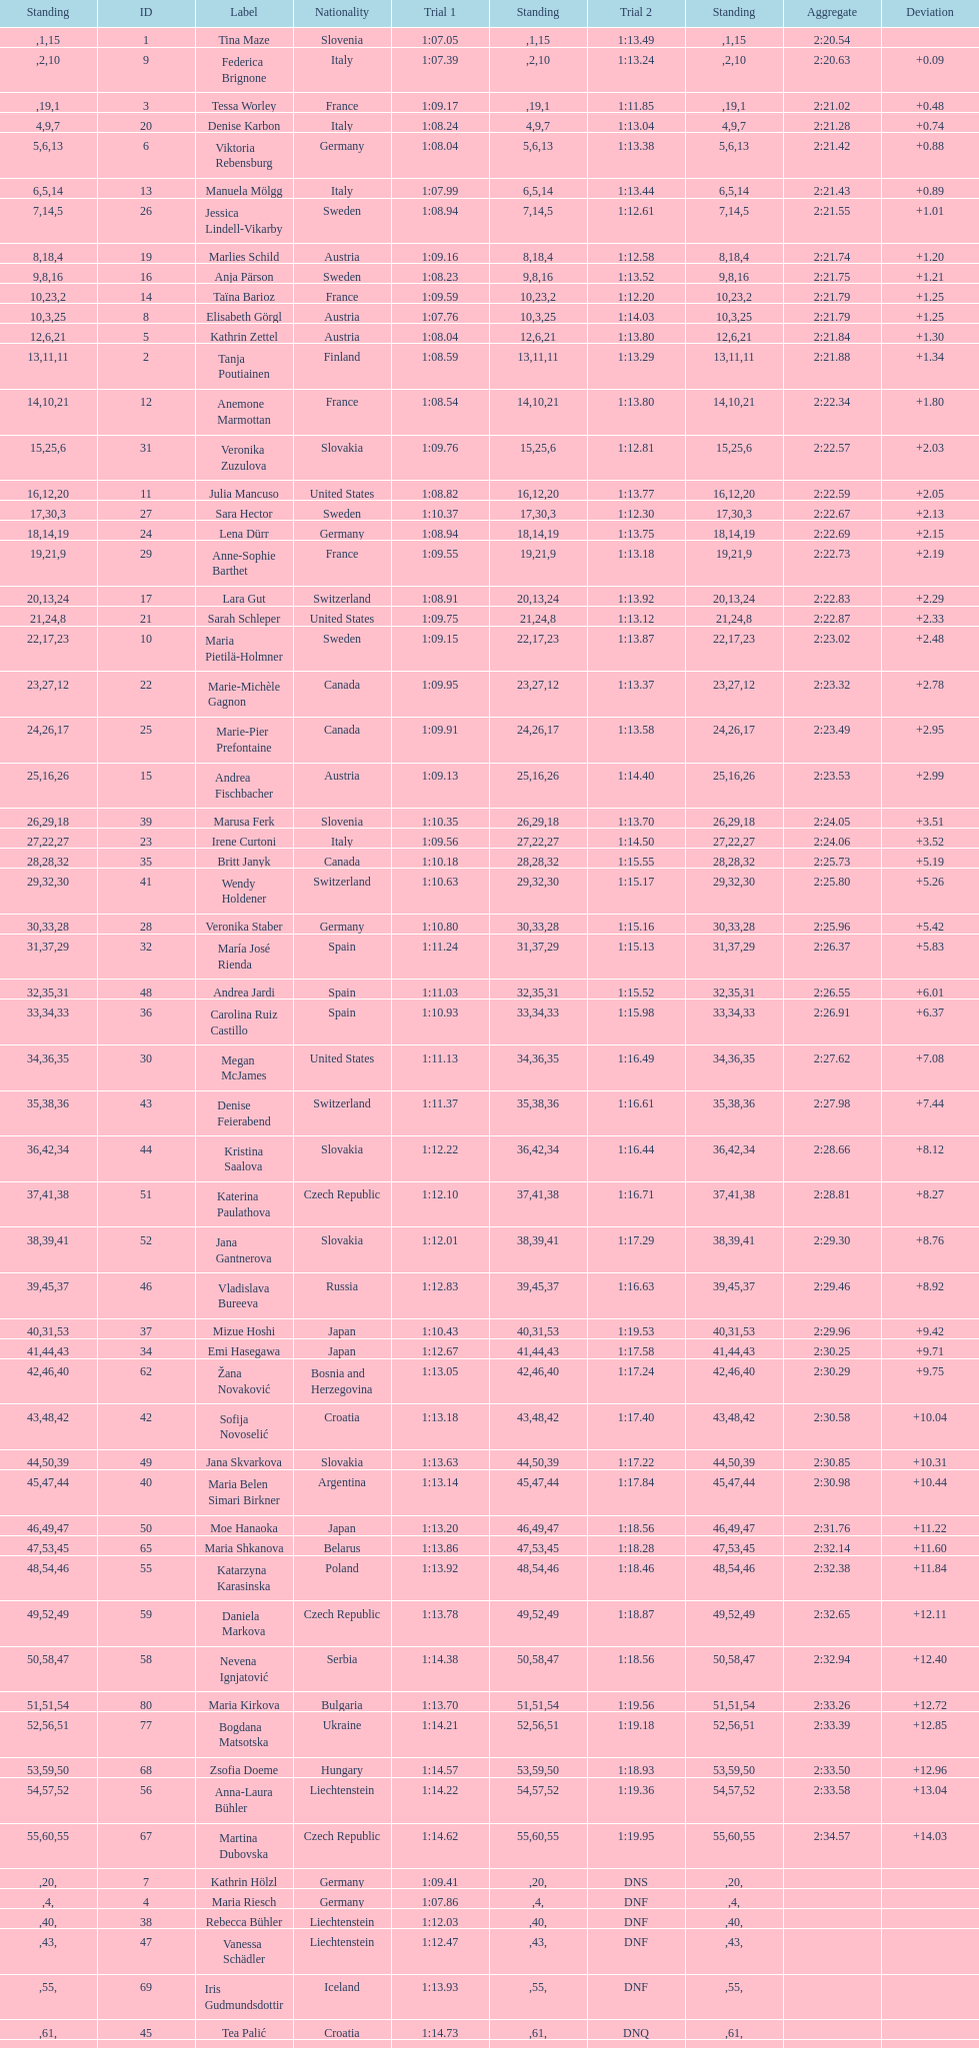How many athletes had the same rank for both run 1 and run 2? 1. 